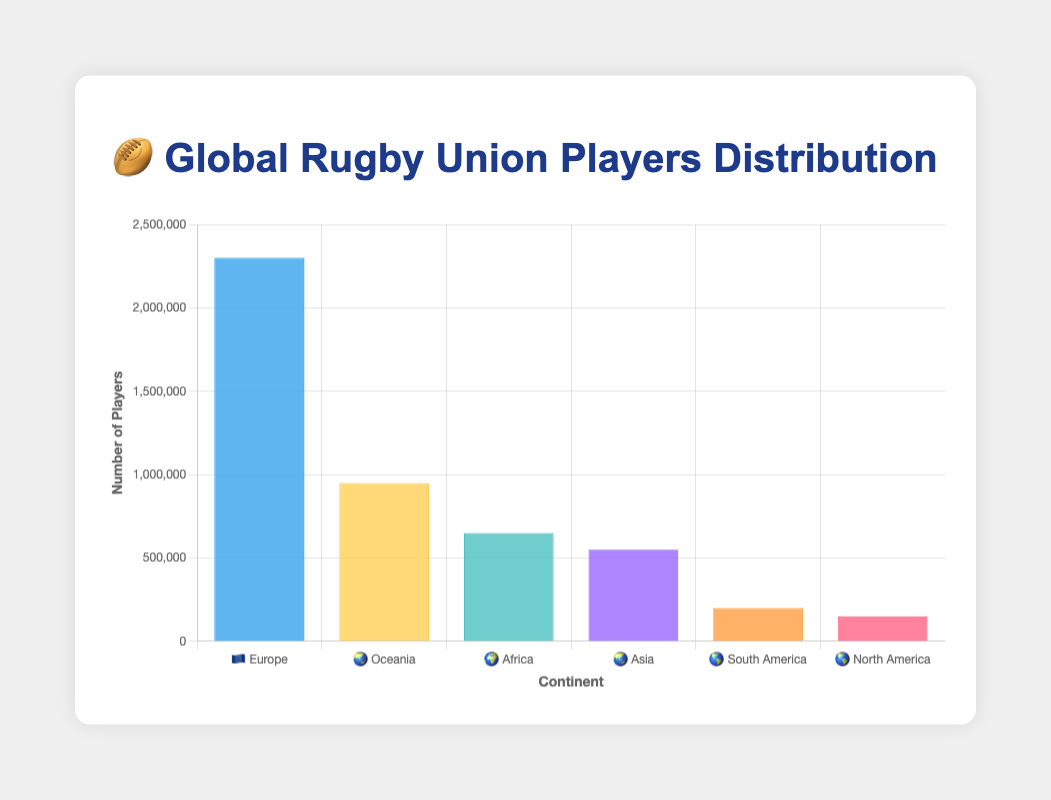How many continents are represented in the chart? To find this, look at how many unique labels (continents) are on the x-axis.
Answer: 6 Which continent has the most registered Rugby Union players? Check the label on the x-axis with the highest bar. Europe has the highest bar.
Answer: Europe 🇪🇺 What is the total number of registered Rugby Union players in Africa and Asia? Add the number of players in Africa (650,000) and Asia (550,000). 650,000 + 550,000 = 1,200,000
Answer: 1,200,000 How does the number of registered players in North America compare to South America? Compare the height of the bars corresponding to North America and South America. North America has fewer players (150,000) than South America (200,000).
Answer: South America has more players Which continent has the fewest registered Rugby Union players? Find the continent with the smallest bar height. North America has the smallest bar.
Answer: North America 🌎 What is the average number of registered Rugby Union players across all continents? Sum the number of players in all continents and divide by the number of continents. (2,300,000 + 950,000 + 650,000 + 550,000 + 200,000 + 150,000) / 6 = 800,000
Answer: 800,000 How many more registered Rugby Union players are there in Europe than all of Asia and Oceania combined? Subtract the total number of players in Asia and Oceania from Europe's players. 2,300,000 - (550,000 + 950,000) = 800,000
Answer: 800,000 Can you identify if there’s a significant disparity in the number of players between continents? Compare the heights of the bars. Europe has a much higher bar than others, indicating a significant disparity.
Answer: Yes, there is a significant disparity If Africa and Asia combined their registered players, how would their total compare to Europe's? Calculate the total for Africa and Asia, and then compare it to Europe. (650,000 + 550,000 = 1,200,000), Europe's players are 2,300,000 which is more.
Answer: Europe has more players What is the difference in the number of registered players between the continent with the most players and the continent with the second-most players? Subtract the number of players in the continent with the second-most players (Oceania) from Europe. 2,300,000 - 950,000 = 1,350,000
Answer: 1,350,000 